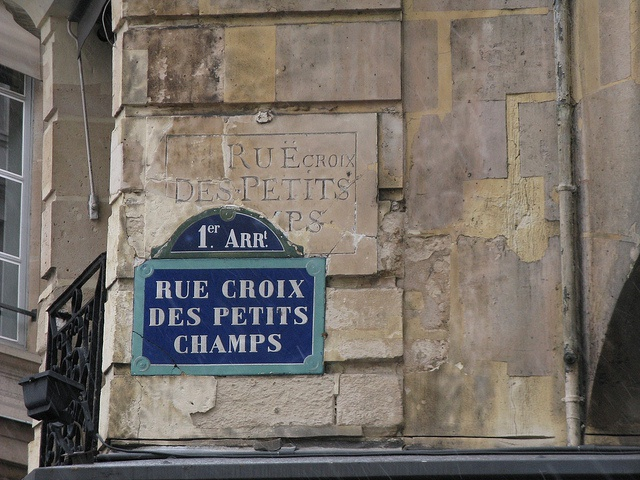Describe the objects in this image and their specific colors. I can see various objects in this image with different colors. 